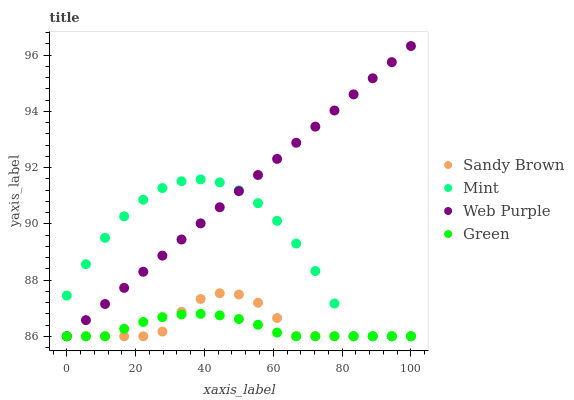Does Green have the minimum area under the curve?
Answer yes or no. Yes. Does Web Purple have the maximum area under the curve?
Answer yes or no. Yes. Does Web Purple have the minimum area under the curve?
Answer yes or no. No. Does Green have the maximum area under the curve?
Answer yes or no. No. Is Web Purple the smoothest?
Answer yes or no. Yes. Is Mint the roughest?
Answer yes or no. Yes. Is Green the smoothest?
Answer yes or no. No. Is Green the roughest?
Answer yes or no. No. Does Mint have the lowest value?
Answer yes or no. Yes. Does Web Purple have the highest value?
Answer yes or no. Yes. Does Green have the highest value?
Answer yes or no. No. Does Web Purple intersect Green?
Answer yes or no. Yes. Is Web Purple less than Green?
Answer yes or no. No. Is Web Purple greater than Green?
Answer yes or no. No. 